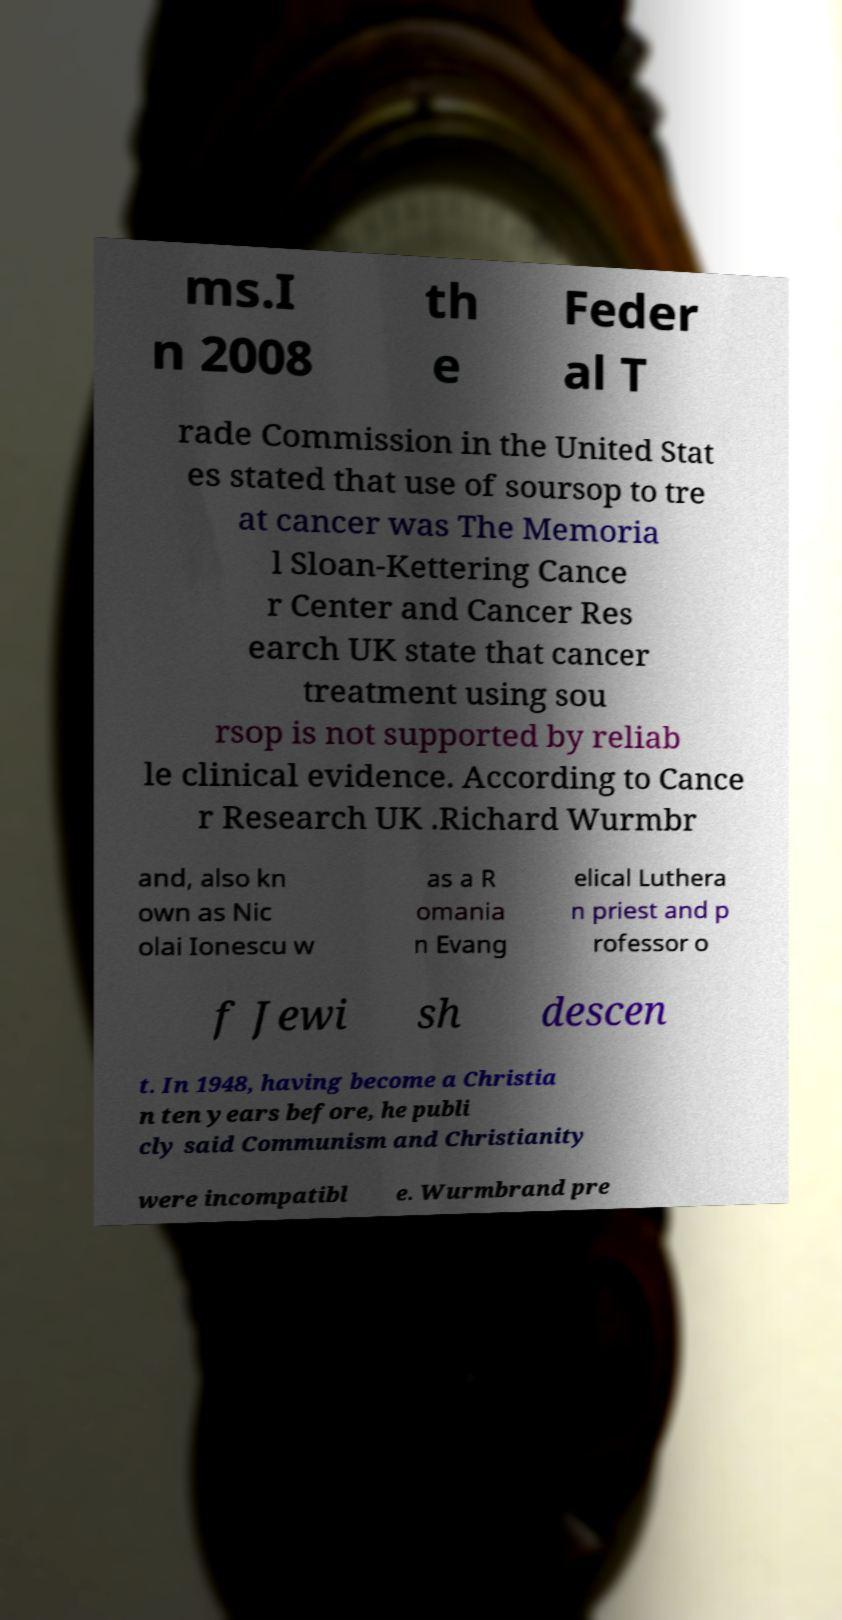Could you assist in decoding the text presented in this image and type it out clearly? ms.I n 2008 th e Feder al T rade Commission in the United Stat es stated that use of soursop to tre at cancer was The Memoria l Sloan-Kettering Cance r Center and Cancer Res earch UK state that cancer treatment using sou rsop is not supported by reliab le clinical evidence. According to Cance r Research UK .Richard Wurmbr and, also kn own as Nic olai Ionescu w as a R omania n Evang elical Luthera n priest and p rofessor o f Jewi sh descen t. In 1948, having become a Christia n ten years before, he publi cly said Communism and Christianity were incompatibl e. Wurmbrand pre 